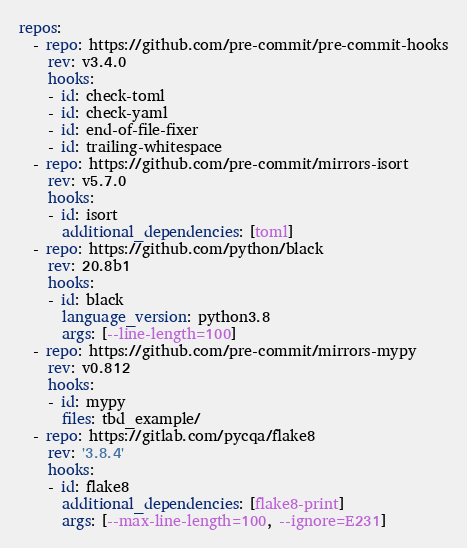<code> <loc_0><loc_0><loc_500><loc_500><_YAML_>repos:
  - repo: https://github.com/pre-commit/pre-commit-hooks
    rev: v3.4.0
    hooks:
    - id: check-toml
    - id: check-yaml
    - id: end-of-file-fixer
    - id: trailing-whitespace
  - repo: https://github.com/pre-commit/mirrors-isort
    rev: v5.7.0
    hooks:
    - id: isort
      additional_dependencies: [toml]
  - repo: https://github.com/python/black
    rev: 20.8b1
    hooks:
    - id: black
      language_version: python3.8
      args: [--line-length=100]
  - repo: https://github.com/pre-commit/mirrors-mypy
    rev: v0.812
    hooks:
    - id: mypy
      files: tbd_example/
  - repo: https://gitlab.com/pycqa/flake8
    rev: '3.8.4'
    hooks:
    - id: flake8
      additional_dependencies: [flake8-print]
      args: [--max-line-length=100, --ignore=E231]
</code> 